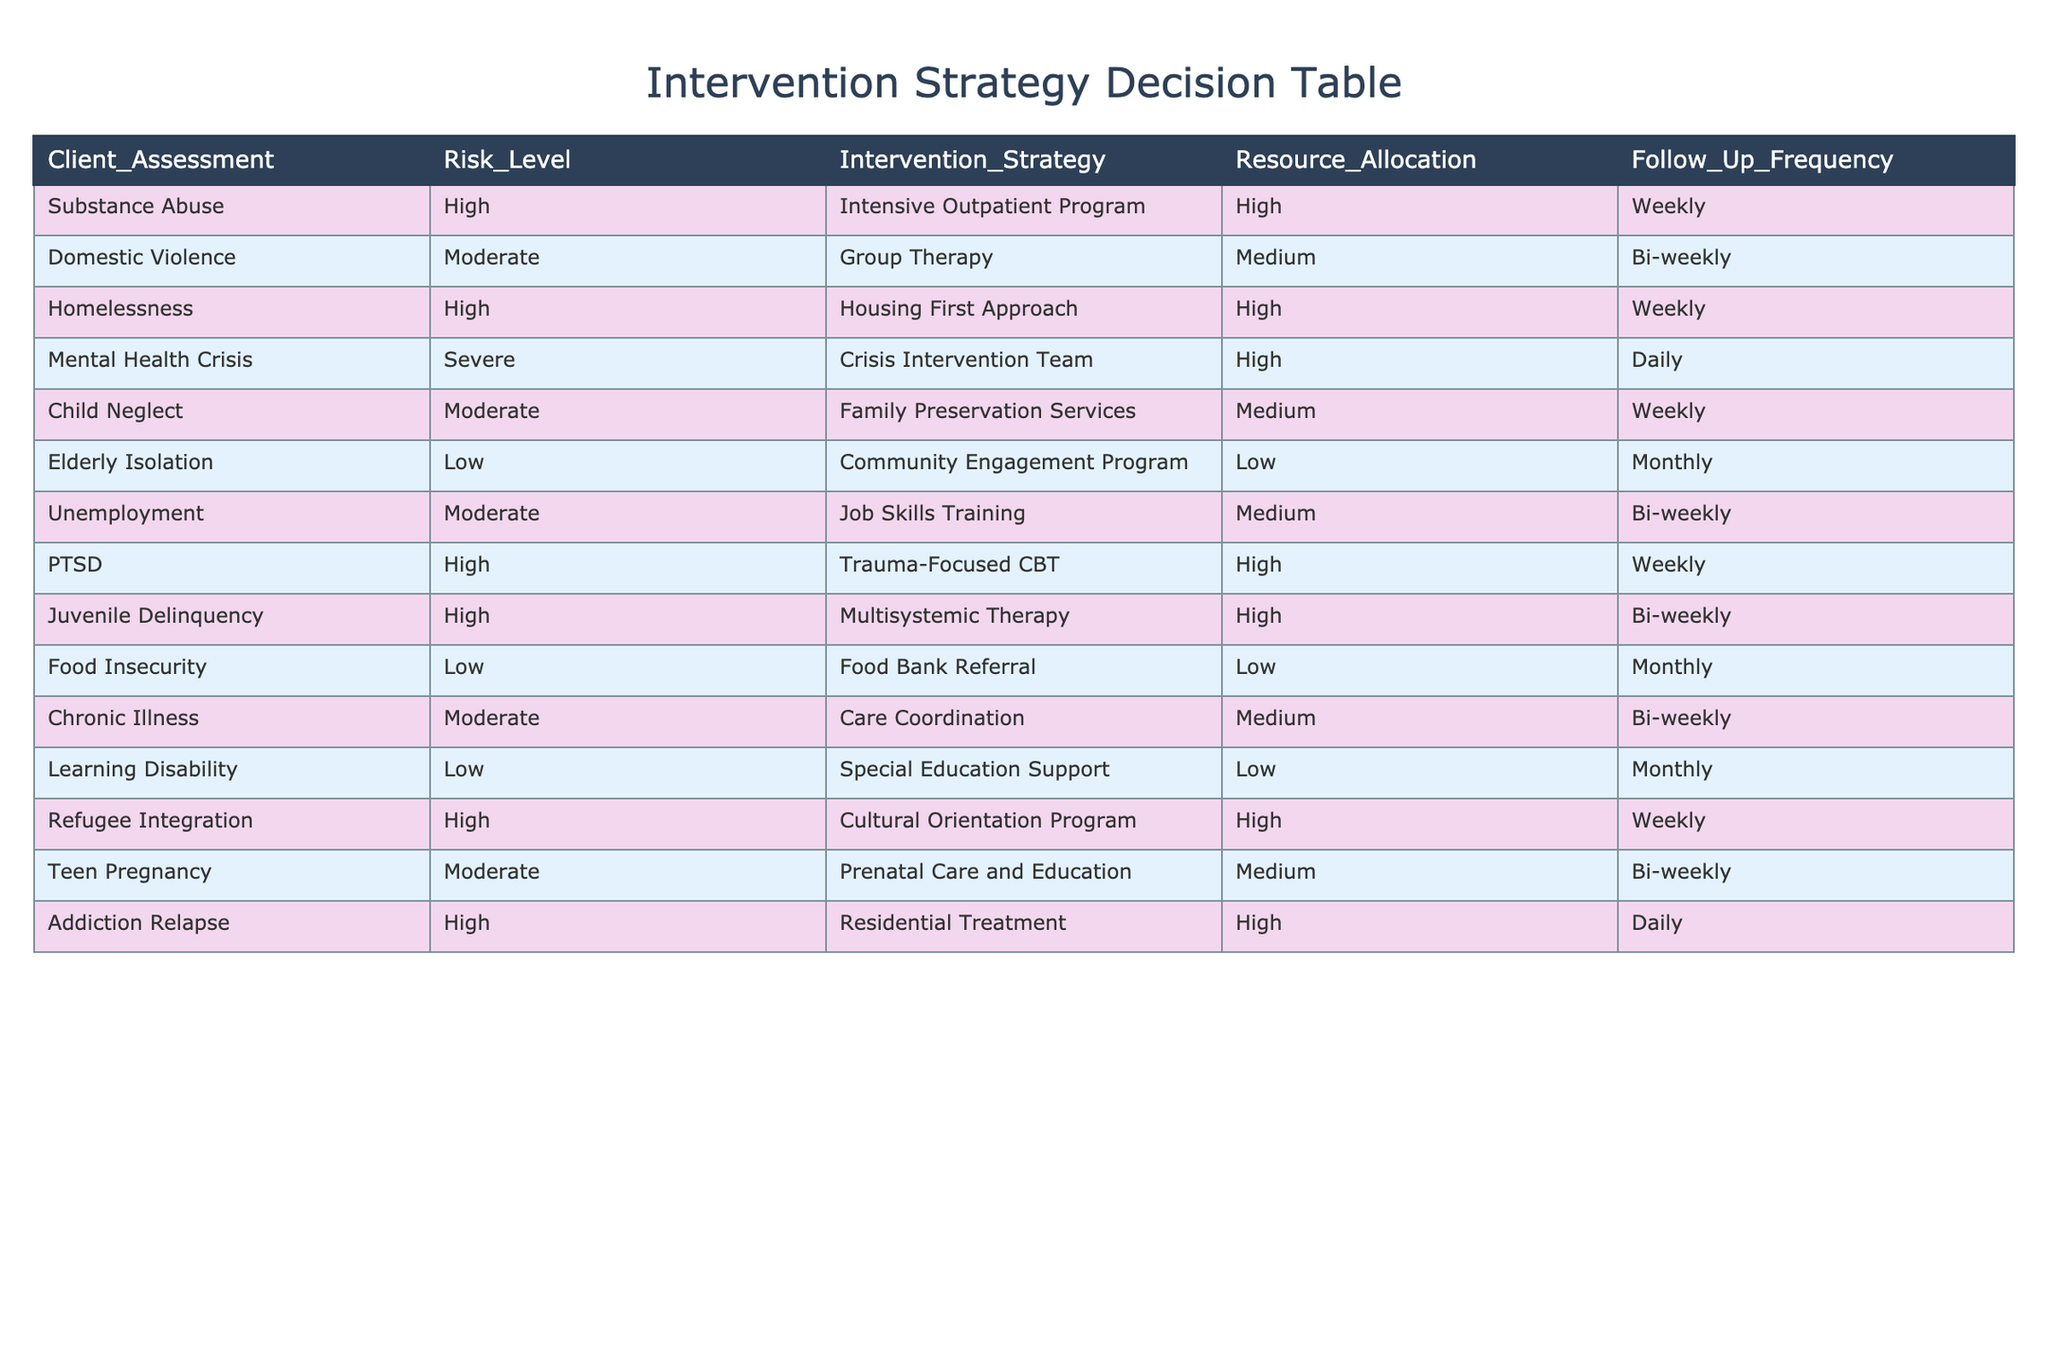What intervention strategy is recommended for clients experiencing high-risk substance abuse? According to the table, clients assessed with high-risk substance abuse are advised to participate in an Intensive Outpatient Program. This information is directly stated in the row corresponding to Substance Abuse and High risk level.
Answer: Intensive Outpatient Program What is the follow-up frequency for clients in a Domestic Violence intervention program? The table indicates that clients receiving Group Therapy for Domestic Violence have a follow-up frequency of Bi-weekly. This is found in the specific row for Domestic Violence.
Answer: Bi-weekly How many intervention strategies are categorized as 'High' resource allocation? By looking at the table, I count four entries with 'High' under the Resource Allocation column: Intensive Outpatient Program, Housing First Approach, Trauma-Focused CBT, and Residential Treatment. Hence, there are four intervention strategies categorized this way.
Answer: 4 Do clients with a Low risk level receive more or fewer resources compared to those with a High risk level? The Low-risk level interventions (Community Engagement Program, Food Bank Referral, and Special Education Support) receive Low resource allocation, whereas all High-risk level interventions receive High resource allocation. This comparison indicates that clients with Low risk level receive fewer resources.
Answer: Fewer resources What is the average follow-up frequency for the strategies aimed at Moderate risk levels? The follow-up frequencies for Moderate risk level strategies (Group Therapy, Family Preservation Services, Job Skills Training, Chronic Illness Care Coordination, and Prenatal Care and Education) are Bi-weekly, Weekly, Bi-weekly, Bi-weekly, and Bi-weekly. Since four out of five are Bi-weekly, and one is Weekly, the average follow-up frequency can be approximated to Bi-weekly, as it is the most recurring frequency among the strategies listed.
Answer: Bi-weekly Which intervention strategy involves the highest follow-up frequency and what is that frequency? The table shows that the strategy with the highest follow-up frequency is the Crisis Intervention Team for Mental Health Crisis, which has a Daily follow-up frequency. The other strategies do not exceed this frequency.
Answer: Daily Is the Cultural Orientation Program suitable for clients with a Low risk level? The table indicates that the Cultural Orientation Program is listed under a High risk level (specifically for Refugee Integration), which implies that it is not suitable for clients categorized as Low risk level.
Answer: No What is the resource allocation distinction between the strategies for clients facing Elderly Isolation and those dealing with Child Neglect? Elderly Isolation receives Low resource allocation with a Community Engagement Program, while Child Neglect, categorized under Moderate risk, receives Medium resource allocation with Family Preservation Services. This comparison shows that resources allocated for Elderly Isolation are lower than for Child Neglect.
Answer: Lower resources for Elderly Isolation 